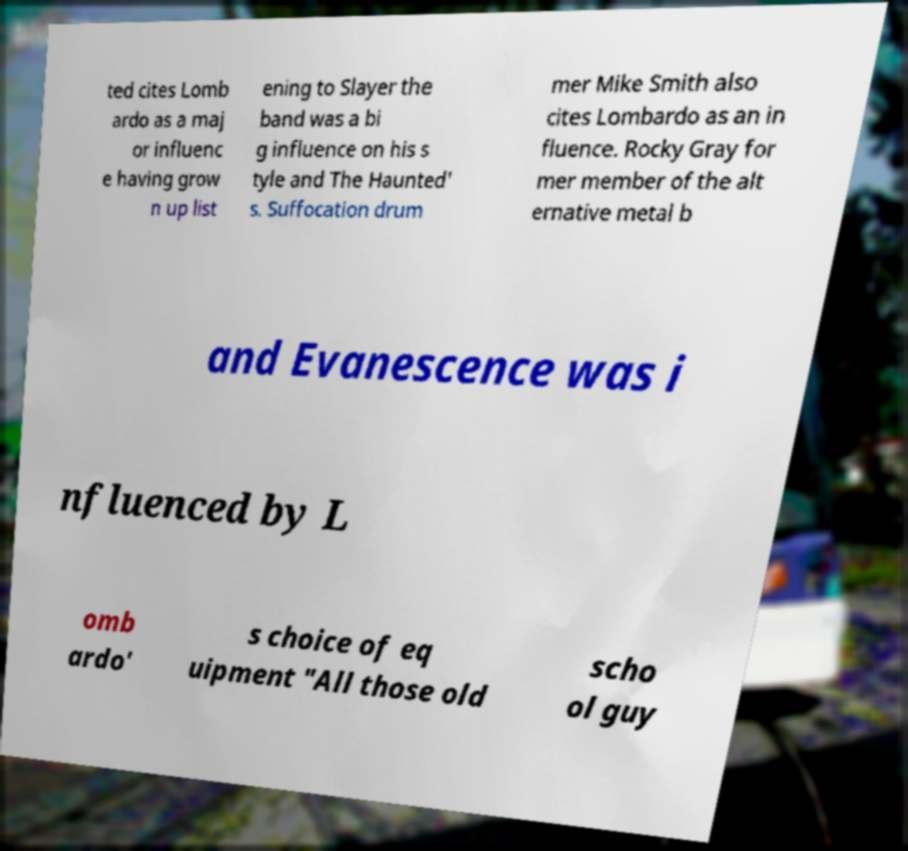I need the written content from this picture converted into text. Can you do that? ted cites Lomb ardo as a maj or influenc e having grow n up list ening to Slayer the band was a bi g influence on his s tyle and The Haunted' s. Suffocation drum mer Mike Smith also cites Lombardo as an in fluence. Rocky Gray for mer member of the alt ernative metal b and Evanescence was i nfluenced by L omb ardo' s choice of eq uipment "All those old scho ol guy 